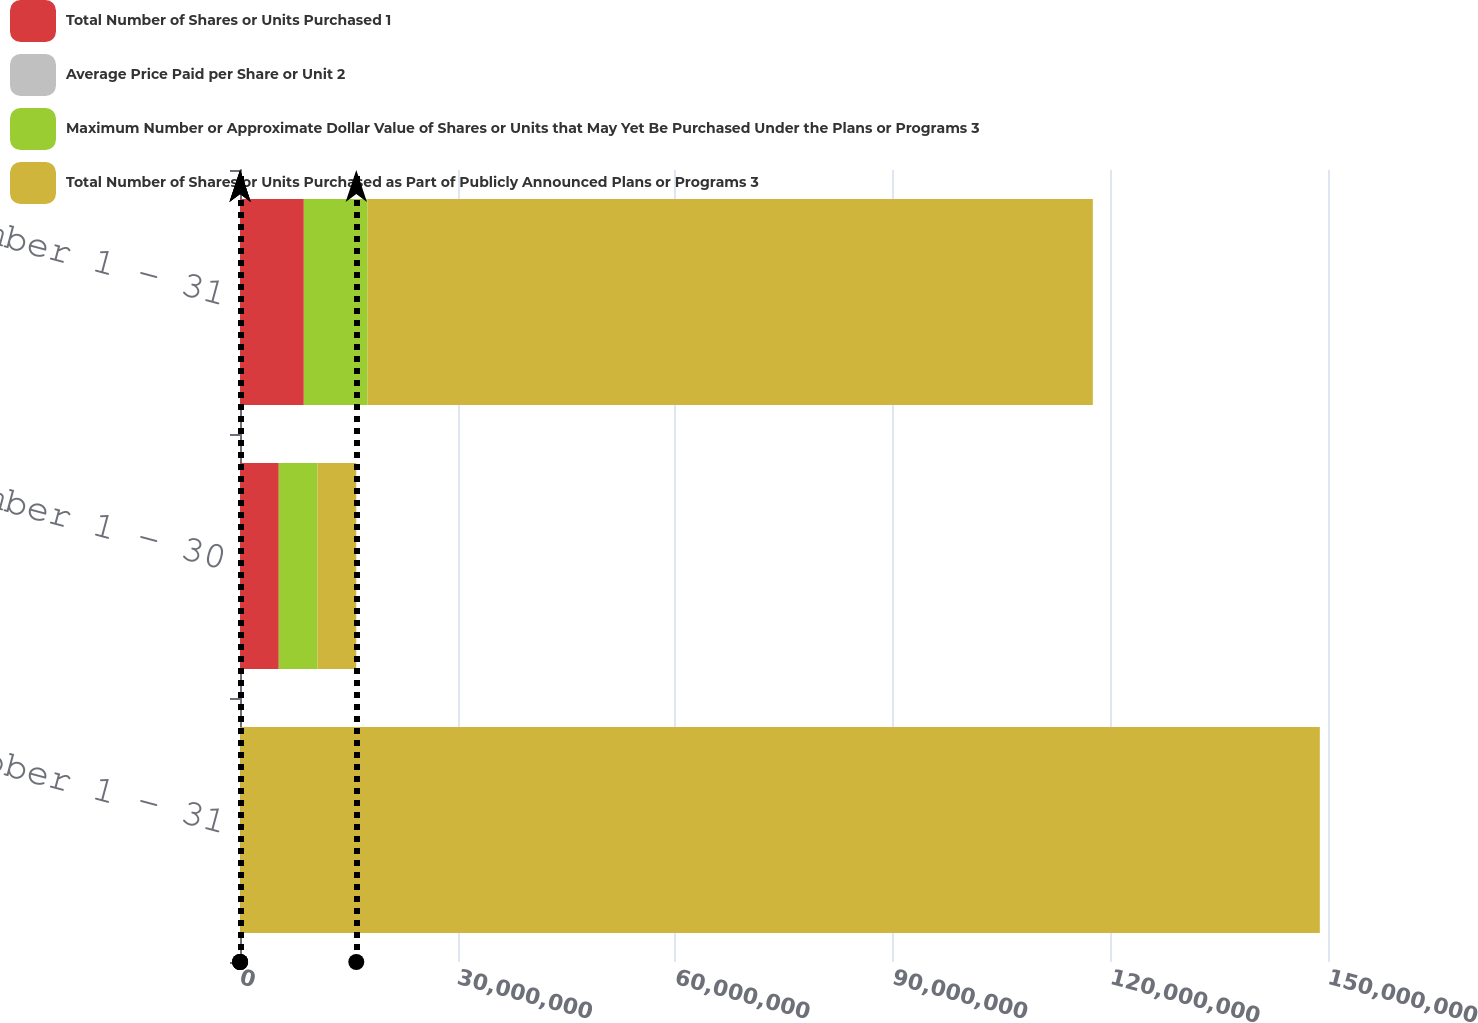Convert chart to OTSL. <chart><loc_0><loc_0><loc_500><loc_500><stacked_bar_chart><ecel><fcel>October 1 - 31<fcel>November 1 - 30<fcel>December 1 - 31<nl><fcel>Total Number of Shares or Units Purchased 1<fcel>13566<fcel>5.34517e+06<fcel>8.79796e+06<nl><fcel>Average Price Paid per Share or Unit 2<fcel>10.26<fcel>9.98<fcel>10.87<nl><fcel>Maximum Number or Approximate Dollar Value of Shares or Units that May Yet Be Purchased Under the Plans or Programs 3<fcel>0<fcel>5.34375e+06<fcel>8.79e+06<nl><fcel>Total Number of Shares or Units Purchased as Part of Publicly Announced Plans or Programs 3<fcel>1.48859e+08<fcel>5.34375e+06<fcel>9.99893e+07<nl></chart> 